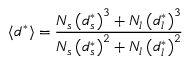<formula> <loc_0><loc_0><loc_500><loc_500>\langle d ^ { * } \rangle = \frac { N _ { s } \left ( d _ { s } ^ { * } \right ) ^ { 3 } + N _ { l } \left ( d _ { l } ^ { * } \right ) ^ { 3 } } { N _ { s } \left ( d _ { s } ^ { * } \right ) ^ { 2 } + N _ { l } \left ( d _ { l } ^ { * } \right ) ^ { 2 } }</formula> 